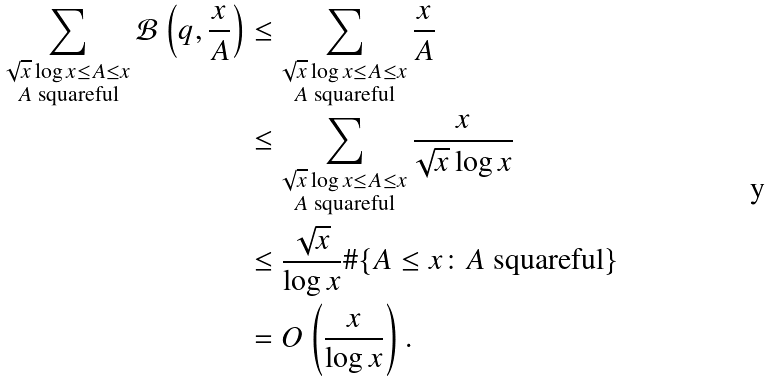Convert formula to latex. <formula><loc_0><loc_0><loc_500><loc_500>\sum _ { \substack { \sqrt { x } \log x \leq A \leq x \\ \text {$A$ squareful} } } \mathcal { B } \left ( q , \frac { x } { A } \right ) & \leq \sum _ { \substack { \sqrt { x } \log x \leq A \leq x \\ \text {$A$ squareful} } } \frac { x } { A } \\ & \leq \sum _ { \substack { \sqrt { x } \log x \leq A \leq x \\ \text {$A$ squareful} } } \frac { x } { \sqrt { x } \log x } \\ & \leq \frac { \sqrt { x } } { \log x } \# \{ A \leq x \colon \text {$A$ squareful} \} \\ & = O \left ( \frac { x } { \log x } \right ) .</formula> 